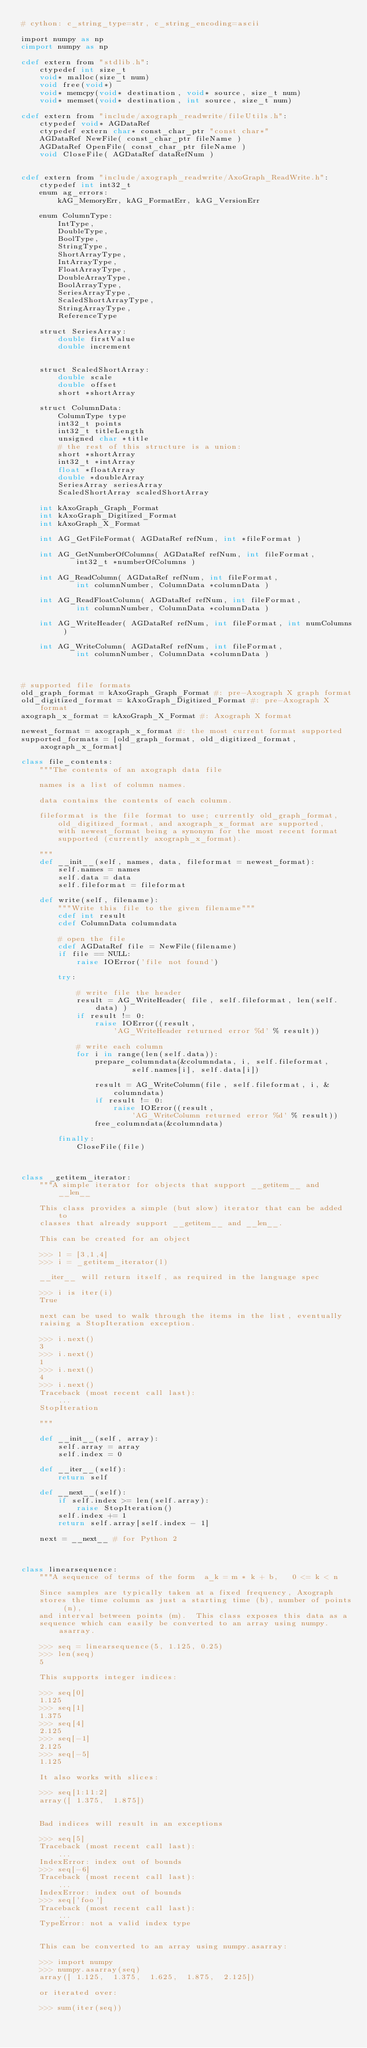<code> <loc_0><loc_0><loc_500><loc_500><_Cython_># cython: c_string_type=str, c_string_encoding=ascii

import numpy as np
cimport numpy as np

cdef extern from "stdlib.h":
    ctypedef int size_t
    void* malloc(size_t num)
    void free(void*)
    void* memcpy(void* destination, void* source, size_t num)
    void* memset(void* destination, int source, size_t num)

cdef extern from "include/axograph_readwrite/fileUtils.h":
    ctypedef void* AGDataRef
    ctypedef extern char* const_char_ptr "const char*"
    AGDataRef NewFile( const_char_ptr fileName )
    AGDataRef OpenFile( const_char_ptr fileName )
    void CloseFile( AGDataRef dataRefNum )


cdef extern from "include/axograph_readwrite/AxoGraph_ReadWrite.h":
    ctypedef int int32_t
    enum ag_errors:
        kAG_MemoryErr, kAG_FormatErr, kAG_VersionErr

    enum ColumnType:
        IntType,
        DoubleType,
        BoolType,
        StringType,
        ShortArrayType,
        IntArrayType,
        FloatArrayType,
        DoubleArrayType,
        BoolArrayType,
        SeriesArrayType,
        ScaledShortArrayType,
        StringArrayType,
        ReferenceType

    struct SeriesArray:
        double firstValue
        double increment


    struct ScaledShortArray:
        double scale
        double offset
        short *shortArray

    struct ColumnData:
        ColumnType type
        int32_t points
        int32_t titleLength
        unsigned char *title
        # the rest of this structure is a union:
        short *shortArray
        int32_t *intArray
        float *floatArray
        double *doubleArray
        SeriesArray seriesArray
        ScaledShortArray scaledShortArray

    int kAxoGraph_Graph_Format
    int kAxoGraph_Digitized_Format
    int kAxoGraph_X_Format

    int AG_GetFileFormat( AGDataRef refNum, int *fileFormat )

    int AG_GetNumberOfColumns( AGDataRef refNum, int fileFormat,
            int32_t *numberOfColumns )

    int AG_ReadColumn( AGDataRef refNum, int fileFormat,
            int columnNumber, ColumnData *columnData )

    int AG_ReadFloatColumn( AGDataRef refNum, int fileFormat,
            int columnNumber, ColumnData *columnData )

    int AG_WriteHeader( AGDataRef refNum, int fileFormat, int numColumns )

    int AG_WriteColumn( AGDataRef refNum, int fileFormat,
            int columnNumber, ColumnData *columnData )



# supported file formats
old_graph_format = kAxoGraph_Graph_Format #: pre-Axograph X graph format
old_digitized_format = kAxoGraph_Digitized_Format #: pre-Axograph X format
axograph_x_format = kAxoGraph_X_Format #: Axograph X format

newest_format = axograph_x_format #: the most current format supported
supported_formats = [old_graph_format, old_digitized_format, axograph_x_format]

class file_contents:
    """The contents of an axograph data file

    names is a list of column names.

    data contains the contents of each column.

    fileformat is the file format to use; currently old_graph_format,
        old_digitized_format, and axograph_x_format are supported,
        with newest_format being a synonym for the most recent format
        supported (currently axograph_x_format).

    """
    def __init__(self, names, data, fileformat = newest_format):
        self.names = names
        self.data = data
        self.fileformat = fileformat

    def write(self, filename):
        """Write this file to the given filename"""
        cdef int result
        cdef ColumnData columndata

        # open the file
        cdef AGDataRef file = NewFile(filename)
        if file == NULL:
            raise IOError('file not found')

        try:

            # write file the header
            result = AG_WriteHeader( file, self.fileformat, len(self.data) )
            if result != 0:
                raise IOError((result,
                    'AG_WriteHeader returned error %d' % result))

            # write each column
            for i in range(len(self.data)):
                prepare_columndata(&columndata, i, self.fileformat,
                        self.names[i], self.data[i])

                result = AG_WriteColumn(file, self.fileformat, i, &columndata)
                if result != 0:
                    raise IOError((result,
                        'AG_WriteColumn returned error %d' % result))
                free_columndata(&columndata)

        finally:
            CloseFile(file)



class _getitem_iterator:
    """A simple iterator for objects that support __getitem__ and __len__

    This class provides a simple (but slow) iterator that can be added to
    classes that already support __getitem__ and __len__.

    This can be created for an object

    >>> l = [3,1,4]
    >>> i = _getitem_iterator(l)

    __iter__ will return itself, as required in the language spec

    >>> i is iter(i)
    True

    next can be used to walk through the items in the list, eventually
    raising a StopIteration exception.

    >>> i.next()
    3
    >>> i.next()
    1
    >>> i.next()
    4
    >>> i.next()
    Traceback (most recent call last):
        ...
    StopIteration

    """

    def __init__(self, array):
        self.array = array
        self.index = 0

    def __iter__(self):
        return self

    def __next__(self):
        if self.index >= len(self.array):
            raise StopIteration()
        self.index += 1
        return self.array[self.index - 1]

    next = __next__ # for Python 2



class linearsequence:
    """A sequence of terms of the form  a_k = m * k + b,   0 <= k < n

    Since samples are typically taken at a fixed frequency, Axograph
    stores the time column as just a starting time (b), number of points (n),
    and interval between points (m).  This class exposes this data as a
    sequence which can easily be converted to an array using numpy.asarray.

    >>> seq = linearsequence(5, 1.125, 0.25)
    >>> len(seq)
    5

    This supports integer indices:

    >>> seq[0]
    1.125
    >>> seq[1]
    1.375
    >>> seq[4]
    2.125
    >>> seq[-1]
    2.125
    >>> seq[-5]
    1.125

    It also works with slices:

    >>> seq[1:11:2]
    array([ 1.375,  1.875])


    Bad indices will result in an exceptions

    >>> seq[5]
    Traceback (most recent call last):
        ...
    IndexError: index out of bounds
    >>> seq[-6]
    Traceback (most recent call last):
        ...
    IndexError: index out of bounds
    >>> seq['foo']
    Traceback (most recent call last):
        ...
    TypeError: not a valid index type


    This can be converted to an array using numpy.asarray:

    >>> import numpy
    >>> numpy.asarray(seq)
    array([ 1.125,  1.375,  1.625,  1.875,  2.125])

    or iterated over:

    >>> sum(iter(seq))</code> 